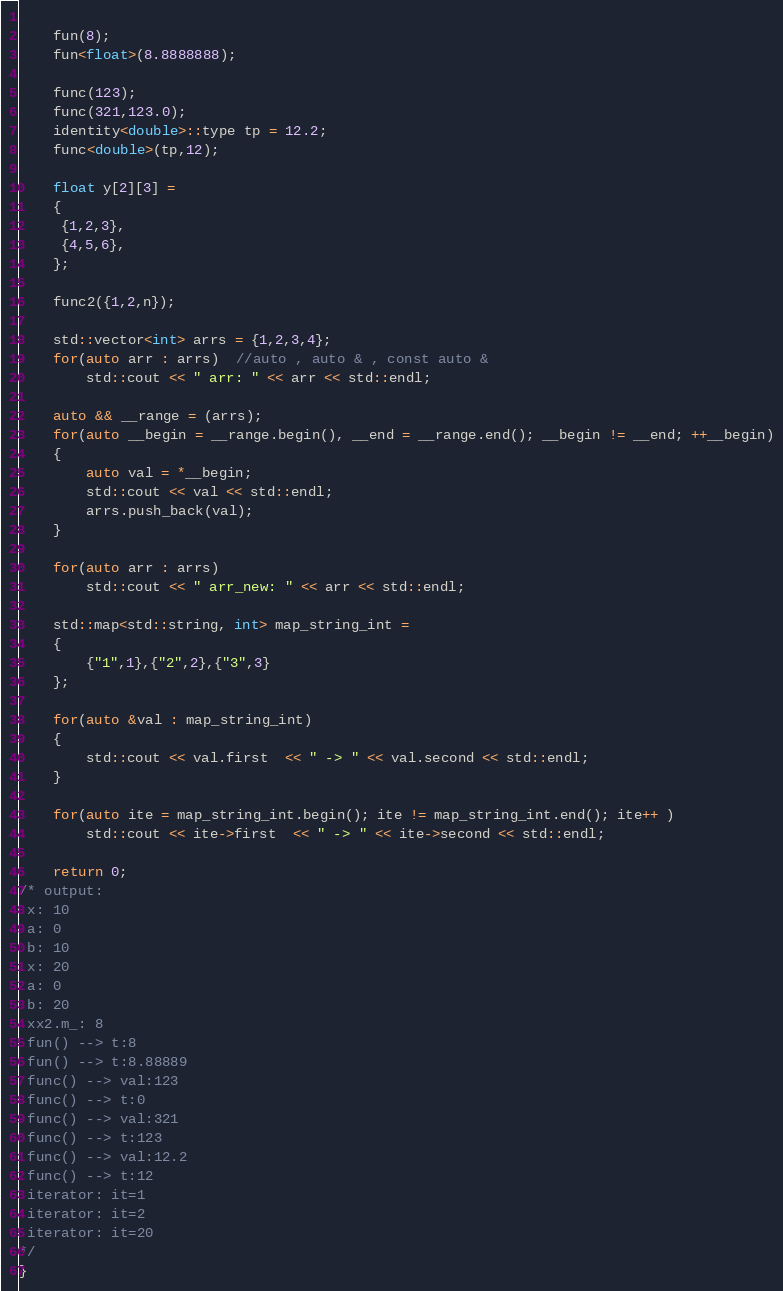<code> <loc_0><loc_0><loc_500><loc_500><_C++_>
   
    fun(8); 
    fun<float>(8.8888888);
    
    func(123);
    func(321,123.0);
    identity<double>::type tp = 12.2;
    func<double>(tp,12);

    float y[2][3] =
    {
     {1,2,3},
     {4,5,6},
    };    

    func2({1,2,n});

    std::vector<int> arrs = {1,2,3,4};
    for(auto arr : arrs)  //auto , auto & , const auto &
        std::cout << " arr: " << arr << std::endl;

    auto && __range = (arrs);
    for(auto __begin = __range.begin(), __end = __range.end(); __begin != __end; ++__begin)
    {
        auto val = *__begin;
        std::cout << val << std::endl;
        arrs.push_back(val); 
    }

    for(auto arr : arrs)
        std::cout << " arr_new: " << arr << std::endl;

    std::map<std::string, int> map_string_int = 
    {
        {"1",1},{"2",2},{"3",3}
    };

    for(auto &val : map_string_int)
    {
        std::cout << val.first  << " -> " << val.second << std::endl;
    }

    for(auto ite = map_string_int.begin(); ite != map_string_int.end(); ite++ )
        std::cout << ite->first  << " -> " << ite->second << std::endl;

    return 0;
/* output: 
 x: 10
 a: 0
 b: 10
 x: 20
 a: 0
 b: 20
 xx2.m_: 8
 fun() --> t:8
 fun() --> t:8.88889
 func() --> val:123
 func() --> t:0
 func() --> val:321
 func() --> t:123
 func() --> val:12.2
 func() --> t:12
 iterator: it=1
 iterator: it=2
 iterator: it=20
*/
}
</code> 